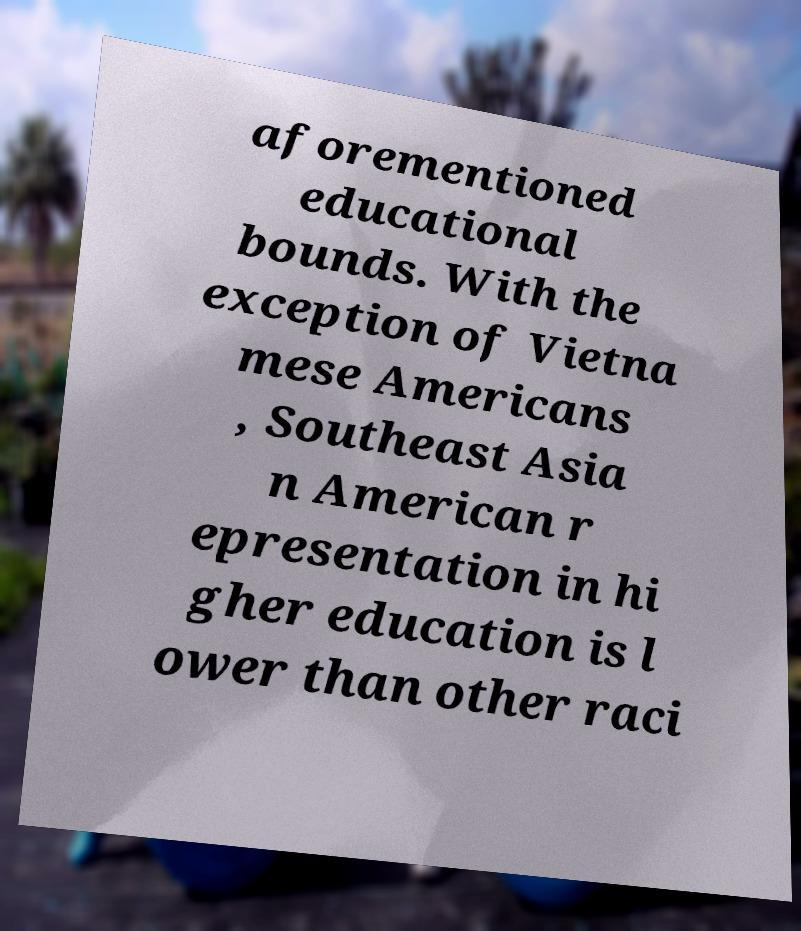For documentation purposes, I need the text within this image transcribed. Could you provide that? aforementioned educational bounds. With the exception of Vietna mese Americans , Southeast Asia n American r epresentation in hi gher education is l ower than other raci 